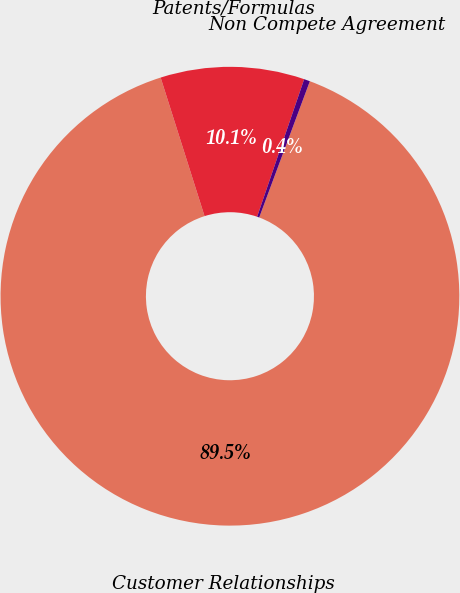<chart> <loc_0><loc_0><loc_500><loc_500><pie_chart><fcel>Customer Relationships<fcel>Patents/Formulas<fcel>Non Compete Agreement<nl><fcel>89.45%<fcel>10.13%<fcel>0.42%<nl></chart> 